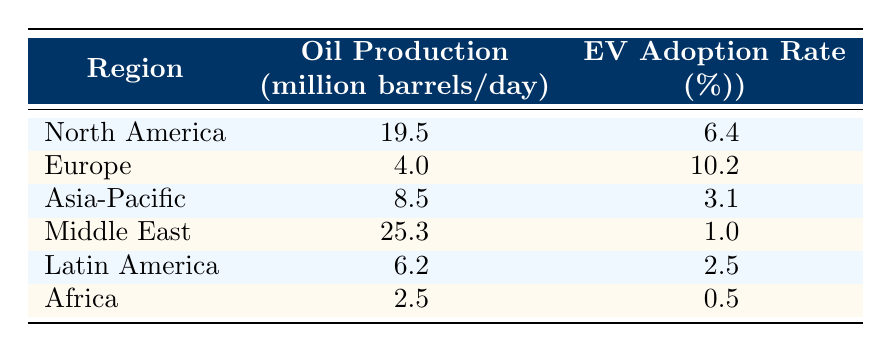What is the oil production level in North America? According to the table, North America's oil production is listed directly under the corresponding row. It shows "19.5" million barrels per day.
Answer: 19.5 What is the electric vehicle adoption rate in Europe? The table indicates that Europe has an electric vehicle adoption rate, and by looking at the data in its row, it shows "10.2" percent.
Answer: 10.2 Which region has the lowest electric vehicle adoption rate? From the table, we compare the electric vehicle adoption rates of each region. Africa has the lowest rate, shown as "0.5" percent.
Answer: Africa Is the oil production in the Middle East higher than in Asia-Pacific? We compare the figures for both regions: Middle East shows "25.3" million barrels per day while Asia-Pacific shows "8.5". Since 25.3 is greater than 8.5, the statement is true.
Answer: Yes What is the average oil production level of all regions listed? To calculate the average, we first sum the oil production levels: 19.5 + 4.0 + 8.5 + 25.3 + 6.2 + 2.5 = 66.0. Then, we divide by the number of regions (6): 66.0 / 6 = 11.0.
Answer: 11.0 If we combine the electric vehicle adoption rates of North America and Europe, what is their total? By adding the rates for both regions from the table, we have North America at "6.4" percent and Europe at "10.2" percent. Thus, 6.4 + 10.2 = 16.6 percent.
Answer: 16.6 Does higher oil production correlate with higher electric vehicle adoption based on the table? We observe the rows and notice that regions with higher oil production (e.g., Middle East) have lower EV adoption rates (1.0%). Conversely, Europe has lower oil production but higher adoption (10.2%). This indicates a negative correlation.
Answer: No What is the difference in electric vehicle adoption rates between North America and Latin America? We take the adoption rates from each region: North America at "6.4" percent and Latin America at "2.5" percent. The difference is computed as 6.4 - 2.5 = 3.9 percent.
Answer: 3.9 Which region's electric vehicle adoption rate is closest to North America's? We compare North America's rate (6.4 percent) with others: Europe (10.2), Asia-Pacific (3.1), Middle East (1.0), Latin America (2.5), and Africa (0.5). The closest is Asia-Pacific at 3.1 percent, as it is less than half away from 6.4.
Answer: Asia-Pacific 